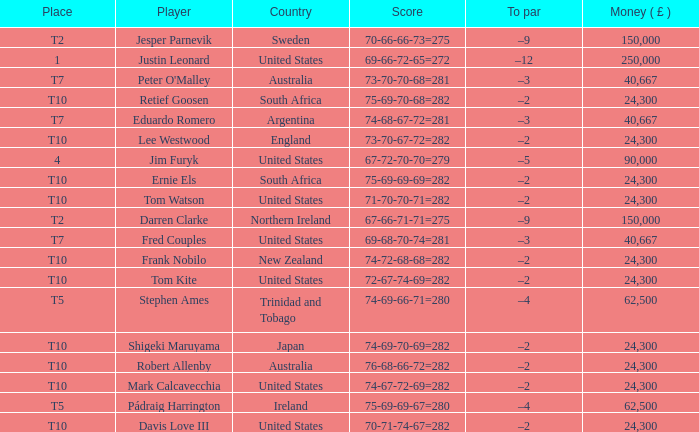What is the money won by Frank Nobilo? 1.0. 